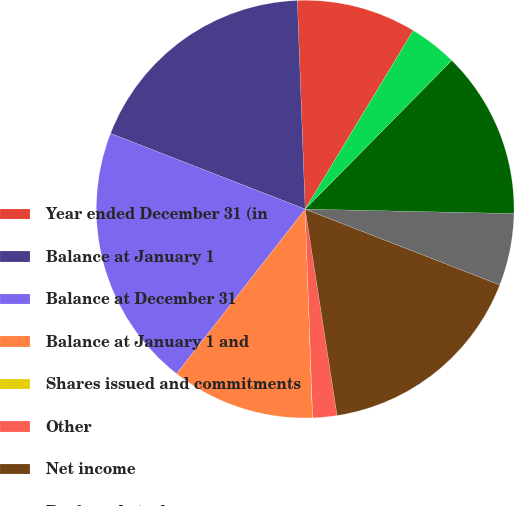<chart> <loc_0><loc_0><loc_500><loc_500><pie_chart><fcel>Year ended December 31 (in<fcel>Balance at January 1<fcel>Balance at December 31<fcel>Balance at January 1 and<fcel>Shares issued and commitments<fcel>Other<fcel>Net income<fcel>Preferred stock<fcel>Common stock ( 272 212 and 188<fcel>Other comprehensive<nl><fcel>9.26%<fcel>18.5%<fcel>20.35%<fcel>11.11%<fcel>0.02%<fcel>1.87%<fcel>16.65%<fcel>5.57%<fcel>12.96%<fcel>3.72%<nl></chart> 